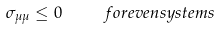<formula> <loc_0><loc_0><loc_500><loc_500>\sigma _ { \mu \mu } \leq 0 \quad \ f o r e v e n s y s t e m s</formula> 